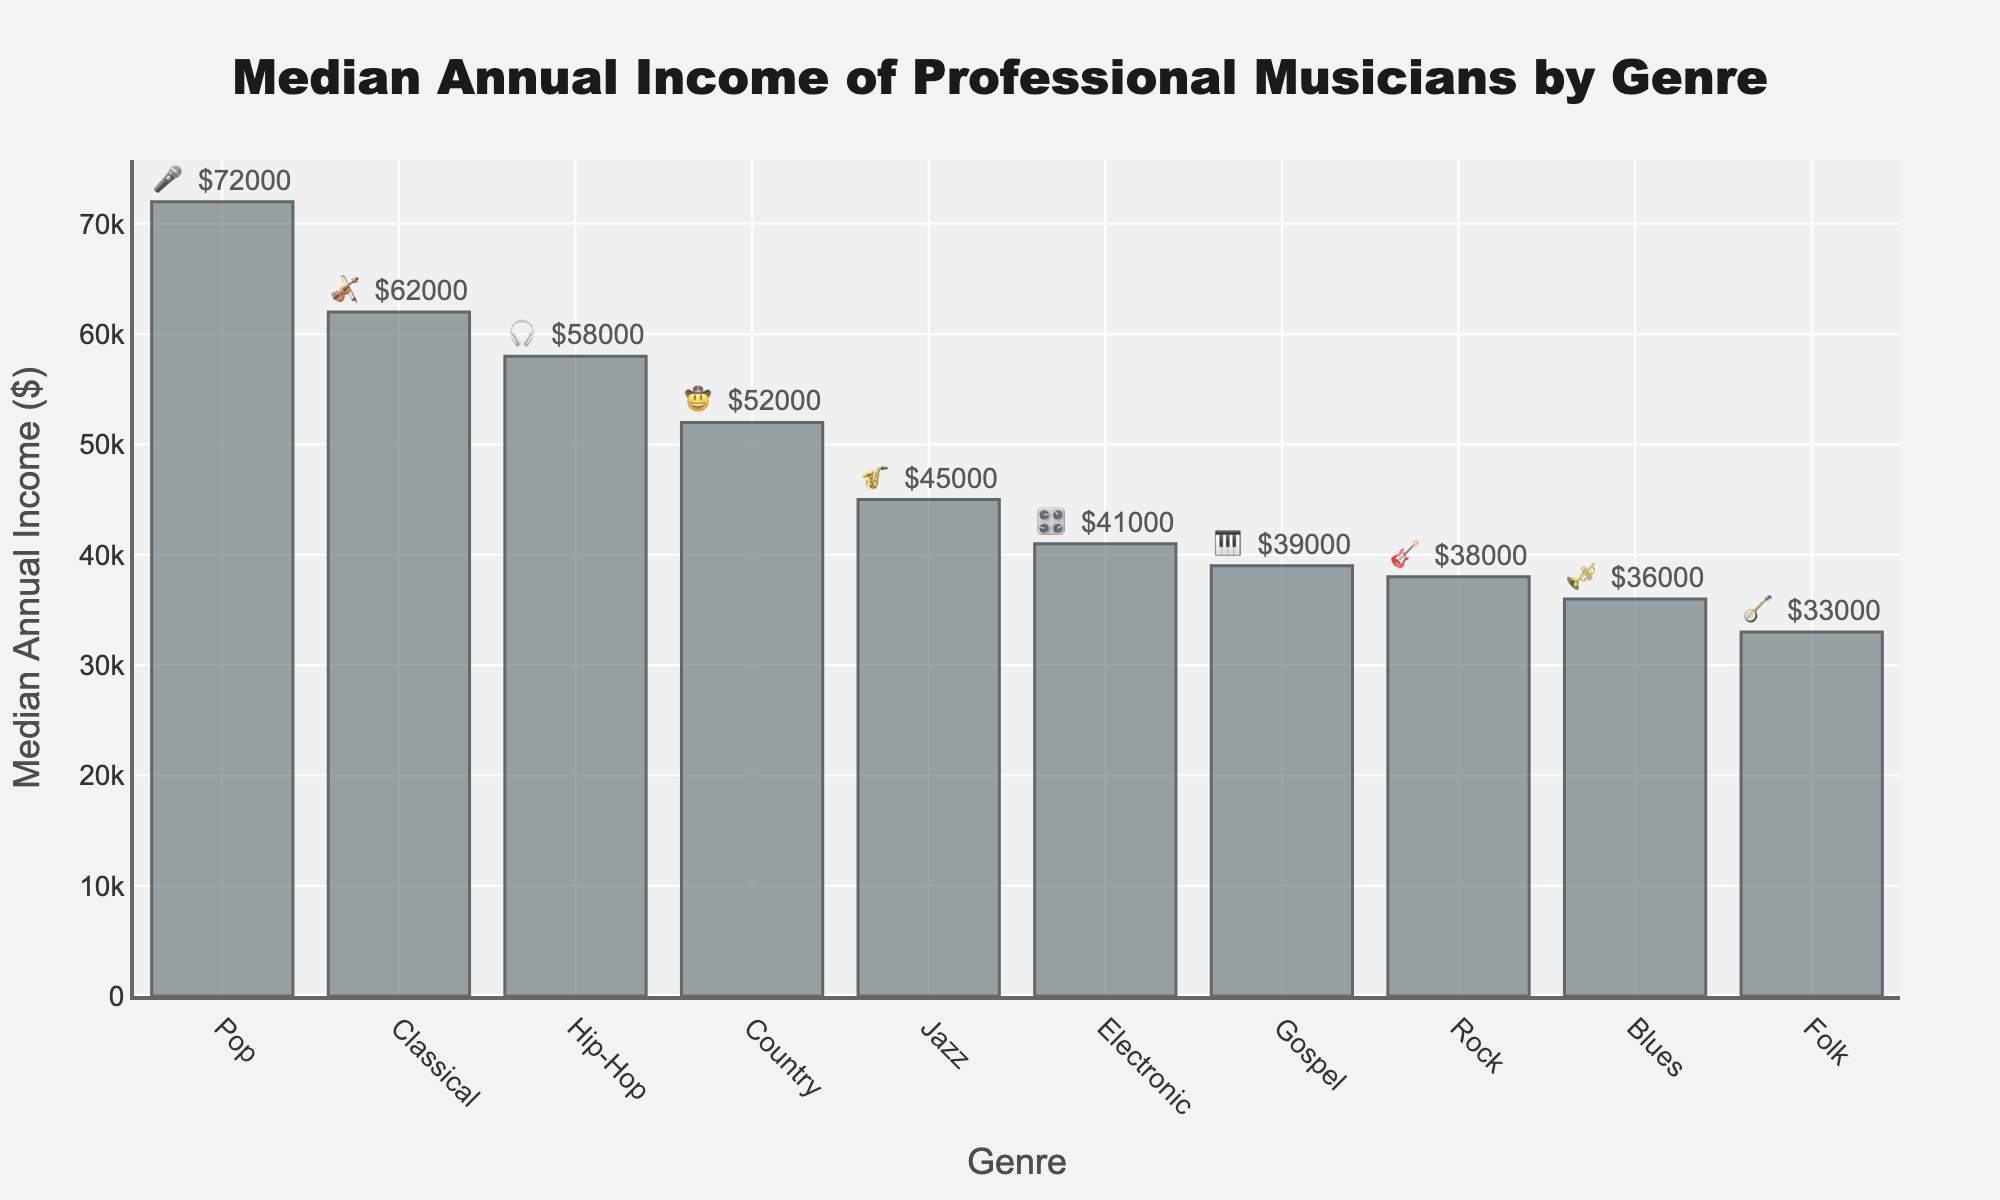what is the genre with the highest median annual income? Look for the bar with the highest height in the plot. The `Pop` genre has the highest median annual income as indicated by the tallest bar. Additionally, the text on top of the bar shows `$72000`.
Answer: Pop what is the median annual income for Jazz musicians? Locate the `Jazz` genre on the x-axis and then look at the y-axis value of its bar. The text on top of the `Jazz` bar shows `$45000`.
Answer: $45000 which genre has a higher median annual income, Classical or Blues? Compare the height of the `Classical` and `Blues` bars. The `Classical` bar is higher with a text of `$62000`, whereas the `Blues` bar has `$36000`.
Answer: Classical how many genres have a median annual income greater than $50,000? Identify the bars taller than the `$50,000` line. The genres include `Classical`, `Pop`, `Country`, and `Hip-Hop` (4 genres).
Answer: 4 what is the difference in median annual income between Electronic and Rock musicians? Subtract the median income of `Rock` from `Electronic`. The `Electronic` bar shows `$41000` and `Rock` shows `$38000`. So, $41000 - $38000.
Answer: $3000 which genre has an emoji that represents a banjo? Look for the genre with the `🪕` emoji in the text labels. The `Folk` genre has this symbol.
Answer: Folk what is the average median annual income across all listed genres? Sum all the median incomes and divide by the number of genres. Total = $62000 + $45000 + $38000 + $72000 + $52000 + $58000 + $41000 + $33000 + $36000 + $39000, then divide by 10.
Answer: $47600 are there more genres with a median income below $50000 or above $50000? Count genres for both conditions. Below $50000 include: `Jazz`, `Rock`, `Electronic`, `Folk`, `Blues`, `Gospel` (6 genres). Above $50000 include: `Classical`, `Pop`, `Country`, `Hip-Hop` (4 genres).
Answer: Below $50000 which genre has the lowest median annual income, and what is its value? Identify the shortest bar in the plot. The `Folk` genre has the lowest median annual income at `$33000`.
Answer: Folk, $33000 